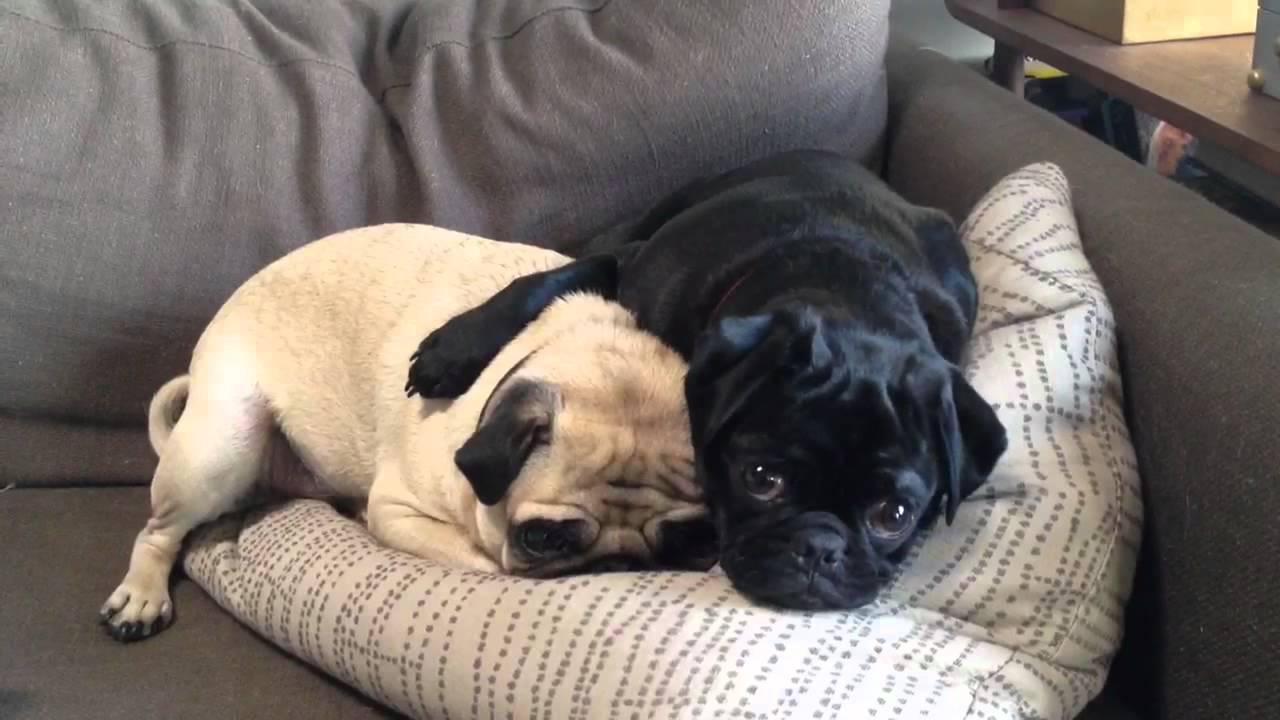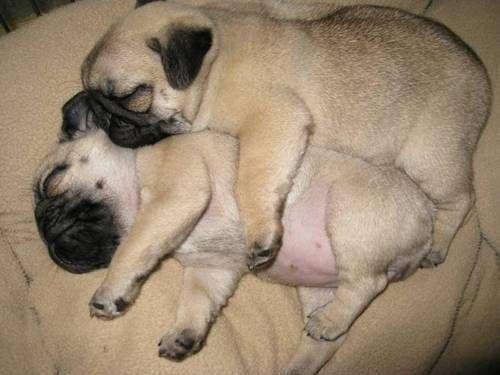The first image is the image on the left, the second image is the image on the right. Evaluate the accuracy of this statement regarding the images: "The left image contains one black dog laying next to one tan dog.". Is it true? Answer yes or no. Yes. The first image is the image on the left, the second image is the image on the right. Evaluate the accuracy of this statement regarding the images: "Two camel-colored pugs relax together on a soft surface, with one posed above the other one.". Is it true? Answer yes or no. Yes. 